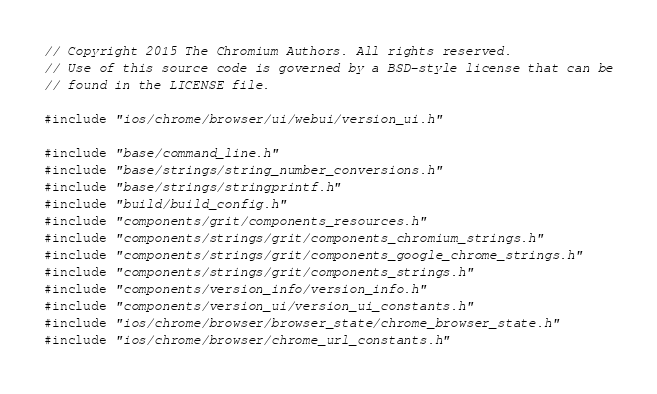<code> <loc_0><loc_0><loc_500><loc_500><_ObjectiveC_>// Copyright 2015 The Chromium Authors. All rights reserved.
// Use of this source code is governed by a BSD-style license that can be
// found in the LICENSE file.

#include "ios/chrome/browser/ui/webui/version_ui.h"

#include "base/command_line.h"
#include "base/strings/string_number_conversions.h"
#include "base/strings/stringprintf.h"
#include "build/build_config.h"
#include "components/grit/components_resources.h"
#include "components/strings/grit/components_chromium_strings.h"
#include "components/strings/grit/components_google_chrome_strings.h"
#include "components/strings/grit/components_strings.h"
#include "components/version_info/version_info.h"
#include "components/version_ui/version_ui_constants.h"
#include "ios/chrome/browser/browser_state/chrome_browser_state.h"
#include "ios/chrome/browser/chrome_url_constants.h"</code> 